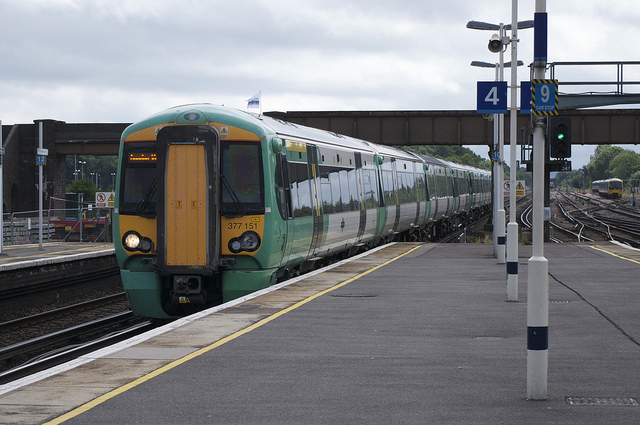<image>What color is the painting on the ground? There is no painting on the ground in the image. What color is the painting on the ground? There is a painting on the ground, and it is yellow. 